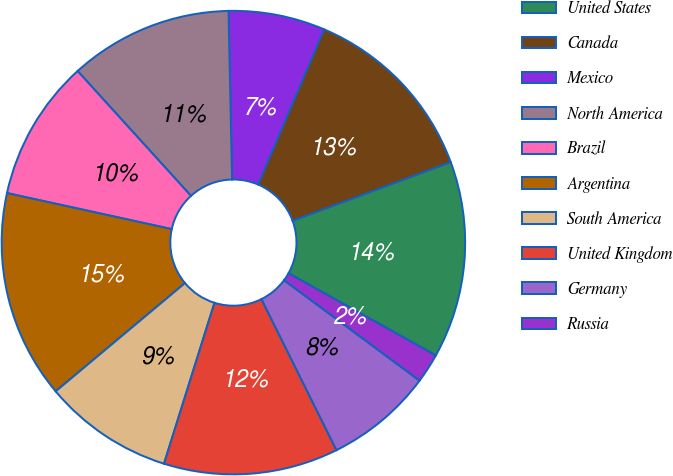Convert chart. <chart><loc_0><loc_0><loc_500><loc_500><pie_chart><fcel>United States<fcel>Canada<fcel>Mexico<fcel>North America<fcel>Brazil<fcel>Argentina<fcel>South America<fcel>United Kingdom<fcel>Germany<fcel>Russia<nl><fcel>13.74%<fcel>12.96%<fcel>6.73%<fcel>11.4%<fcel>9.84%<fcel>14.52%<fcel>9.07%<fcel>12.18%<fcel>7.51%<fcel>2.06%<nl></chart> 